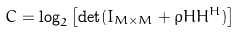<formula> <loc_0><loc_0><loc_500><loc_500>C = \log _ { 2 } \left [ \det ( I _ { M \times M } + \rho H H ^ { H } ) \right ]</formula> 